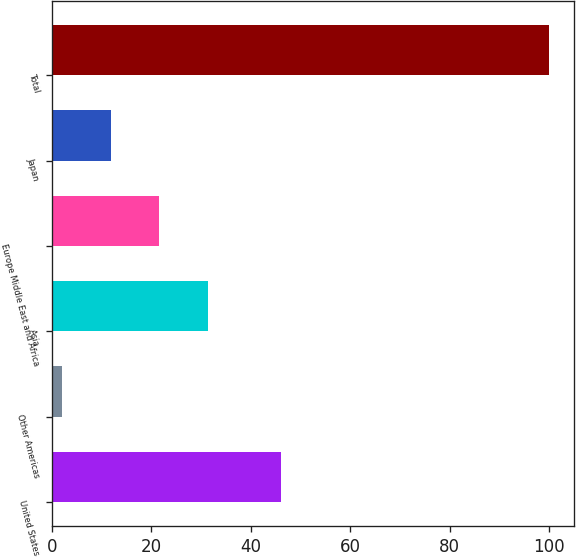Convert chart to OTSL. <chart><loc_0><loc_0><loc_500><loc_500><bar_chart><fcel>United States<fcel>Other Americas<fcel>Asia<fcel>Europe Middle East and Africa<fcel>Japan<fcel>Total<nl><fcel>46<fcel>2<fcel>31.4<fcel>21.6<fcel>11.8<fcel>100<nl></chart> 